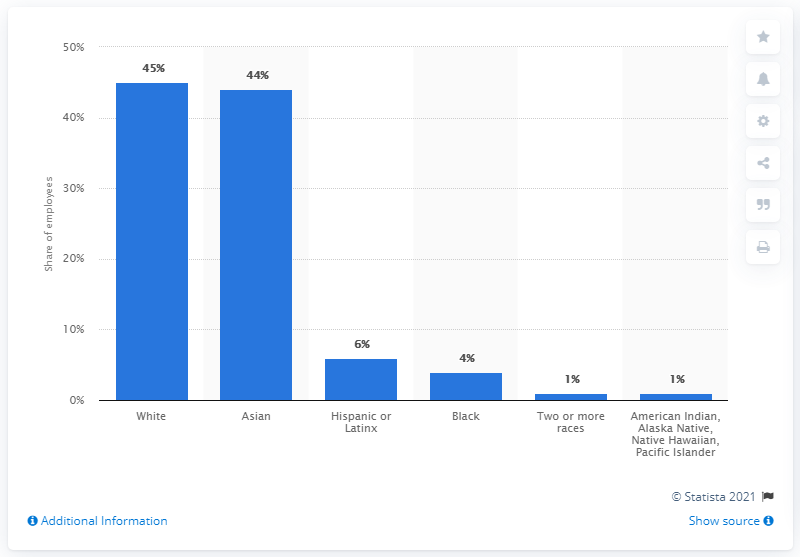Identify some key points in this picture. In 2019, 6% of Pinterest employees in the United States identified as Hispanic or Latinx, according to the company's diversity report. 